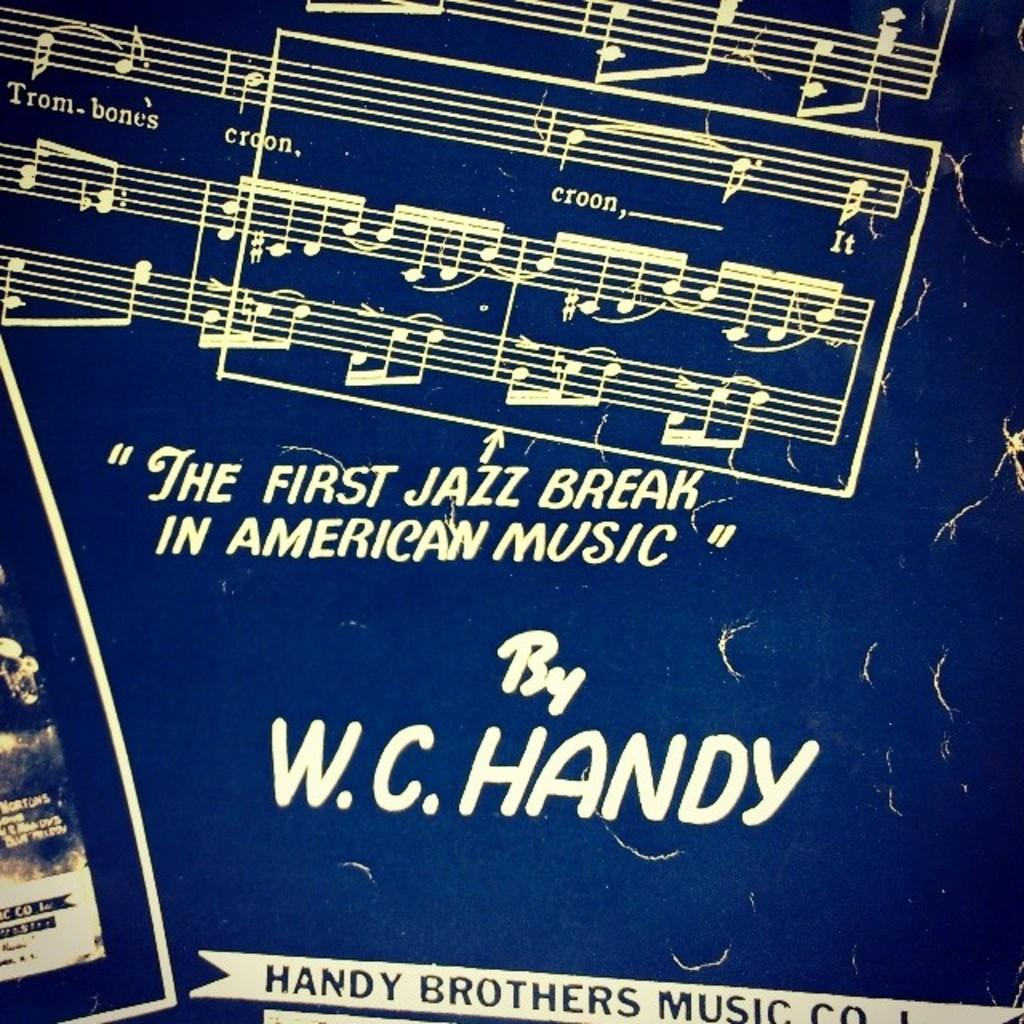Provide a one-sentence caption for the provided image. A poster says "The first jazz break in american music" by W.C. Handy on it. 